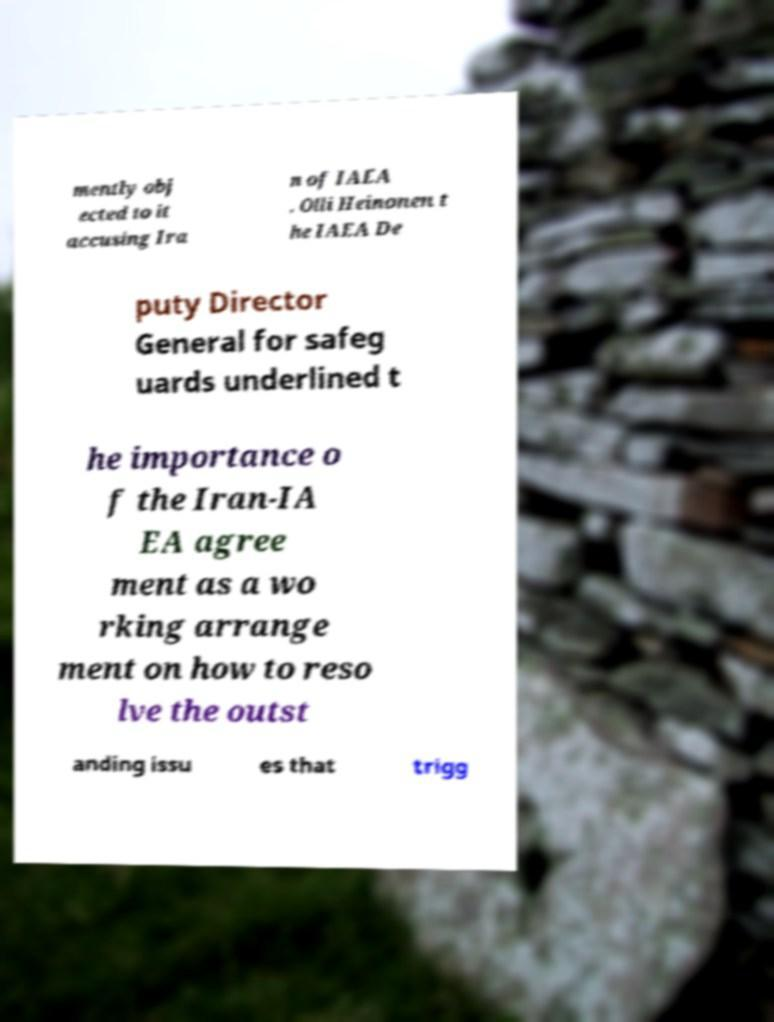Please identify and transcribe the text found in this image. mently obj ected to it accusing Ira n of IAEA . Olli Heinonen t he IAEA De puty Director General for safeg uards underlined t he importance o f the Iran-IA EA agree ment as a wo rking arrange ment on how to reso lve the outst anding issu es that trigg 